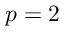Convert formula to latex. <formula><loc_0><loc_0><loc_500><loc_500>p = 2</formula> 